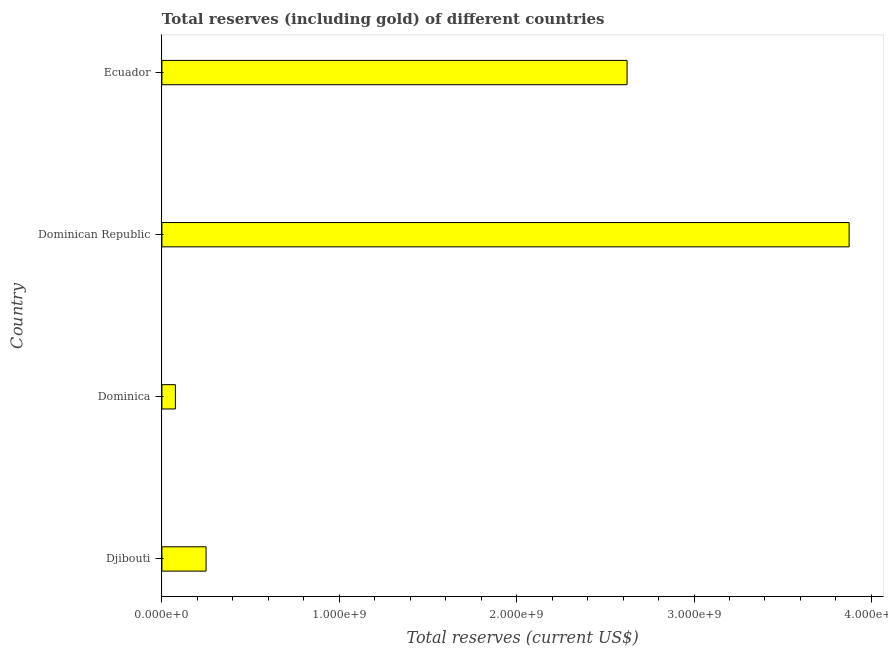Does the graph contain any zero values?
Keep it short and to the point. No. Does the graph contain grids?
Provide a succinct answer. No. What is the title of the graph?
Ensure brevity in your answer.  Total reserves (including gold) of different countries. What is the label or title of the X-axis?
Provide a succinct answer. Total reserves (current US$). What is the label or title of the Y-axis?
Your answer should be compact. Country. What is the total reserves (including gold) in Ecuador?
Give a very brief answer. 2.62e+09. Across all countries, what is the maximum total reserves (including gold)?
Provide a short and direct response. 3.87e+09. Across all countries, what is the minimum total reserves (including gold)?
Offer a very short reply. 7.61e+07. In which country was the total reserves (including gold) maximum?
Offer a very short reply. Dominican Republic. In which country was the total reserves (including gold) minimum?
Give a very brief answer. Dominica. What is the sum of the total reserves (including gold)?
Your response must be concise. 6.82e+09. What is the difference between the total reserves (including gold) in Dominican Republic and Ecuador?
Make the answer very short. 1.25e+09. What is the average total reserves (including gold) per country?
Offer a very short reply. 1.71e+09. What is the median total reserves (including gold)?
Your answer should be very brief. 1.44e+09. What is the ratio of the total reserves (including gold) in Dominican Republic to that in Ecuador?
Make the answer very short. 1.48. Is the total reserves (including gold) in Djibouti less than that in Ecuador?
Your answer should be compact. Yes. What is the difference between the highest and the second highest total reserves (including gold)?
Your response must be concise. 1.25e+09. Is the sum of the total reserves (including gold) in Dominican Republic and Ecuador greater than the maximum total reserves (including gold) across all countries?
Provide a succinct answer. Yes. What is the difference between the highest and the lowest total reserves (including gold)?
Ensure brevity in your answer.  3.80e+09. Are all the bars in the graph horizontal?
Provide a succinct answer. Yes. What is the Total reserves (current US$) in Djibouti?
Your response must be concise. 2.49e+08. What is the Total reserves (current US$) in Dominica?
Offer a very short reply. 7.61e+07. What is the Total reserves (current US$) of Dominican Republic?
Ensure brevity in your answer.  3.87e+09. What is the Total reserves (current US$) of Ecuador?
Make the answer very short. 2.62e+09. What is the difference between the Total reserves (current US$) in Djibouti and Dominica?
Your response must be concise. 1.73e+08. What is the difference between the Total reserves (current US$) in Djibouti and Dominican Republic?
Your answer should be very brief. -3.63e+09. What is the difference between the Total reserves (current US$) in Djibouti and Ecuador?
Your answer should be compact. -2.37e+09. What is the difference between the Total reserves (current US$) in Dominica and Dominican Republic?
Ensure brevity in your answer.  -3.80e+09. What is the difference between the Total reserves (current US$) in Dominica and Ecuador?
Offer a terse response. -2.55e+09. What is the difference between the Total reserves (current US$) in Dominican Republic and Ecuador?
Offer a terse response. 1.25e+09. What is the ratio of the Total reserves (current US$) in Djibouti to that in Dominica?
Ensure brevity in your answer.  3.27. What is the ratio of the Total reserves (current US$) in Djibouti to that in Dominican Republic?
Offer a terse response. 0.06. What is the ratio of the Total reserves (current US$) in Djibouti to that in Ecuador?
Give a very brief answer. 0.1. What is the ratio of the Total reserves (current US$) in Dominica to that in Dominican Republic?
Keep it short and to the point. 0.02. What is the ratio of the Total reserves (current US$) in Dominica to that in Ecuador?
Your response must be concise. 0.03. What is the ratio of the Total reserves (current US$) in Dominican Republic to that in Ecuador?
Offer a terse response. 1.48. 